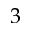Convert formula to latex. <formula><loc_0><loc_0><loc_500><loc_500>3</formula> 